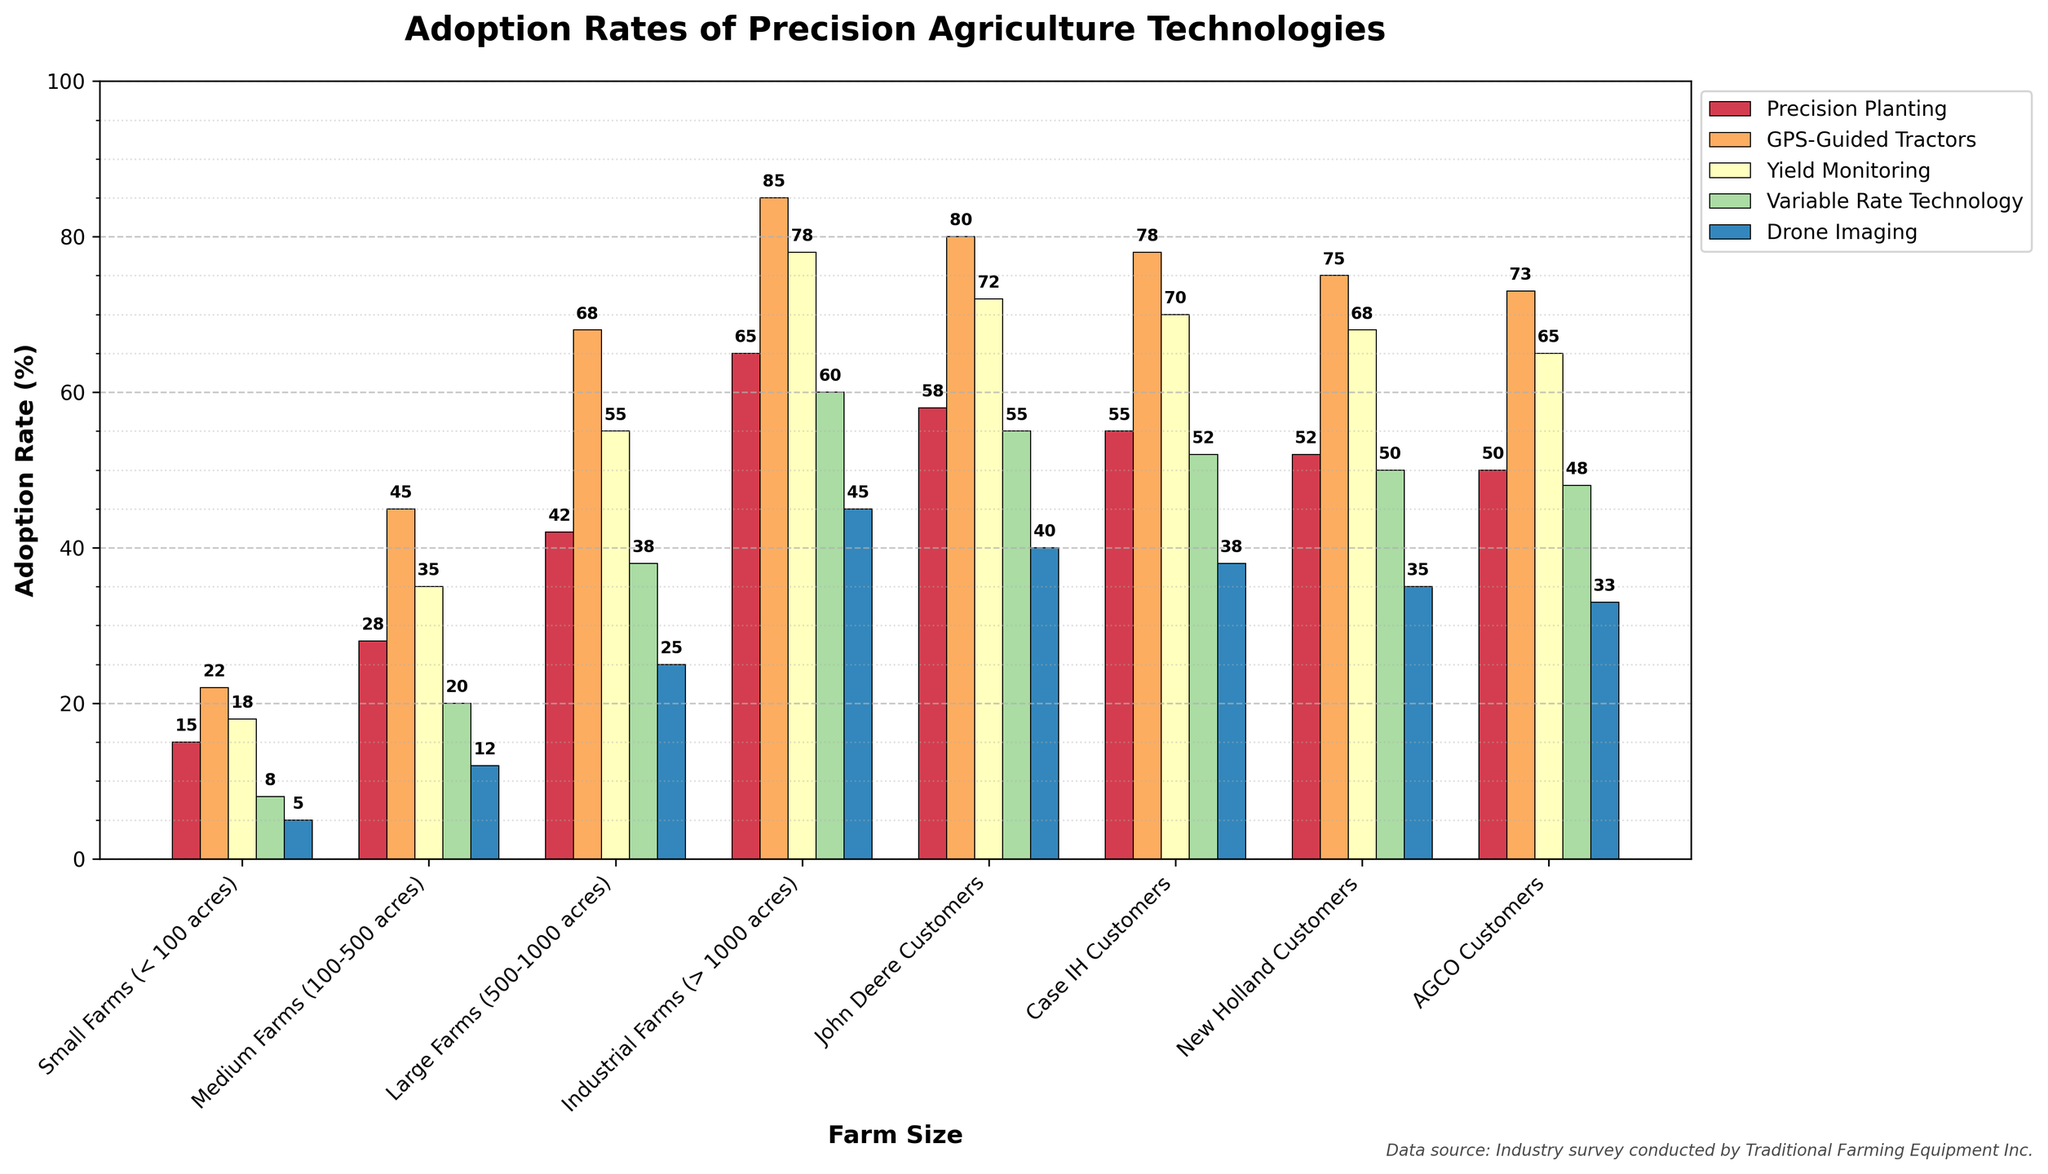Which farm size has the highest adoption rate of GPS-Guided Tractors? Industrial Farms have the highest adoption rate of GPS-Guided Tractors at 85%. By looking at the heights of the bars in the GPS-Guided Tractors category for each farm size, Industrial Farms clearly stand out at the top.
Answer: Industrial Farms What is the difference in adoption rates of Drone Imaging between Small Farms and Industrial Farms? The adoption rate for Drone Imaging is 5% for Small Farms and 45% for Industrial Farms. The difference is calculated as 45% - 5% = 40%.
Answer: 40% Which technology has the lowest adoption rate among Medium Farms? Among Medium Farms, Drone Imaging has the lowest adoption rate at 12%. This can be identified by comparing the heights of the bars representing different technologies for Medium Farms and noting that Drone Imaging has the shortest bar.
Answer: Drone Imaging On average, which category of farms (John Deere, Case IH, New Holland, AGCO customers) has the highest adoption rate for Precision Planting technology? Calculating the average: John Deere (58), Case IH (55), New Holland (52), AGCO (50). The highest adoption rate is for John Deere Customers with 58%.
Answer: John Deere Customers How much higher is the adoption rate of Variable Rate Technology in Large Farms compared to Small Farms? Large Farms have a 38% adoption rate for Variable Rate Technology, while Small Farms have an 8% adoption rate. The difference is 38% - 8% = 30%.
Answer: 30% What is the combined adoption rate of Yield Monitoring and Drone Imaging for Large Farms? The adoption rate for Yield Monitoring in Large Farms is 55%, and for Drone Imaging it is 25%. Combined, this is 55% + 25% = 80%.
Answer: 80% Compare the adoption rates of Precision Planting between AGCO Customers and Medium Farms. Which is higher? AGCO Customers have an adoption rate of 50% for Precision Planting, while Medium Farms have an adoption rate of 28%. Thus, AGCO Customers have a higher adoption rate.
Answer: AGCO Customers Which technology shows the most significant increase in adoption rate from Small Farms to Large Farms? By comparing the increases: 
- Precision Planting: 42% - 15% = 27%
- GPS-Guided Tractors: 68% - 22% = 46%
- Yield Monitoring: 55% - 18% = 37%
- Variable Rate Technology: 38% - 8% = 30%
- Drone Imaging: 25% - 5% = 20%
GPS-Guided Tractors show the most significant increase at 46%.
Answer: GPS-Guided Tractors Which precise agriculture technology has a similar adoption rate among John Deere Customers and Case IH Customers? Yield Monitoring has an adoption rate of 72% for John Deere Customers and 70% for Case IH Customers, showing a small difference. This can be visually compared by looking at the heights of the corresponding bars.
Answer: Yield Monitoring 